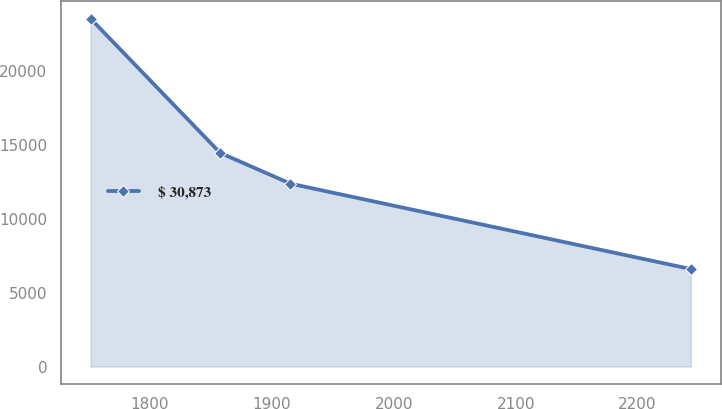<chart> <loc_0><loc_0><loc_500><loc_500><line_chart><ecel><fcel>$ 30,873<nl><fcel>1751.44<fcel>23552.8<nl><fcel>1857.66<fcel>14470.1<nl><fcel>1915.26<fcel>12384.9<nl><fcel>2243.67<fcel>6603.27<nl></chart> 